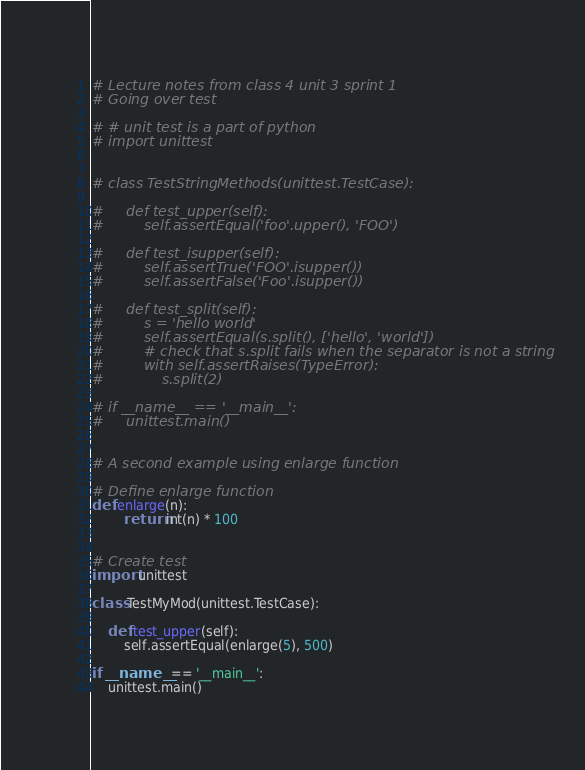Convert code to text. <code><loc_0><loc_0><loc_500><loc_500><_Python_># Lecture notes from class 4 unit 3 sprint 1
# Going over test

# # unit test is a part of python
# import unittest


# class TestStringMethods(unittest.TestCase):

#     def test_upper(self):
#         self.assertEqual('foo'.upper(), 'FOO')

#     def test_isupper(self):
#         self.assertTrue('FOO'.isupper())
#         self.assertFalse('Foo'.isupper())

#     def test_split(self):
#         s = 'hello world'
#         self.assertEqual(s.split(), ['hello', 'world'])
#         # check that s.split fails when the separator is not a string
#         with self.assertRaises(TypeError):
#             s.split(2)

# if __name__ == '__main__':
#     unittest.main()


# A second example using enlarge function

# Define enlarge function
def enlarge(n):
        return int(n) * 100


# Create test
import unittest

class TestMyMod(unittest.TestCase):

    def test_upper(self):
        self.assertEqual(enlarge(5), 500)

if __name__ == '__main__':
    unittest.main()</code> 